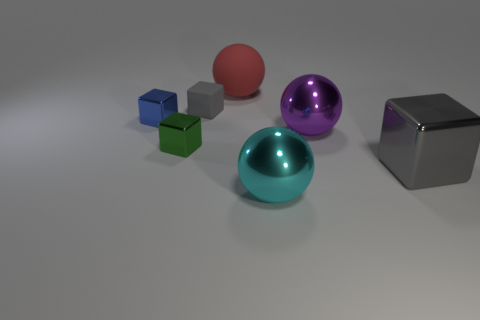Add 2 gray rubber cubes. How many objects exist? 9 Subtract all tiny blocks. How many blocks are left? 1 Subtract all cyan balls. How many balls are left? 2 Subtract 0 red cubes. How many objects are left? 7 Subtract all spheres. How many objects are left? 4 Subtract 2 spheres. How many spheres are left? 1 Subtract all green cubes. Subtract all red balls. How many cubes are left? 3 Subtract all brown blocks. How many red spheres are left? 1 Subtract all purple matte cubes. Subtract all matte cubes. How many objects are left? 6 Add 7 small green metallic blocks. How many small green metallic blocks are left? 8 